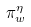<formula> <loc_0><loc_0><loc_500><loc_500>\pi _ { w } ^ { \eta }</formula> 